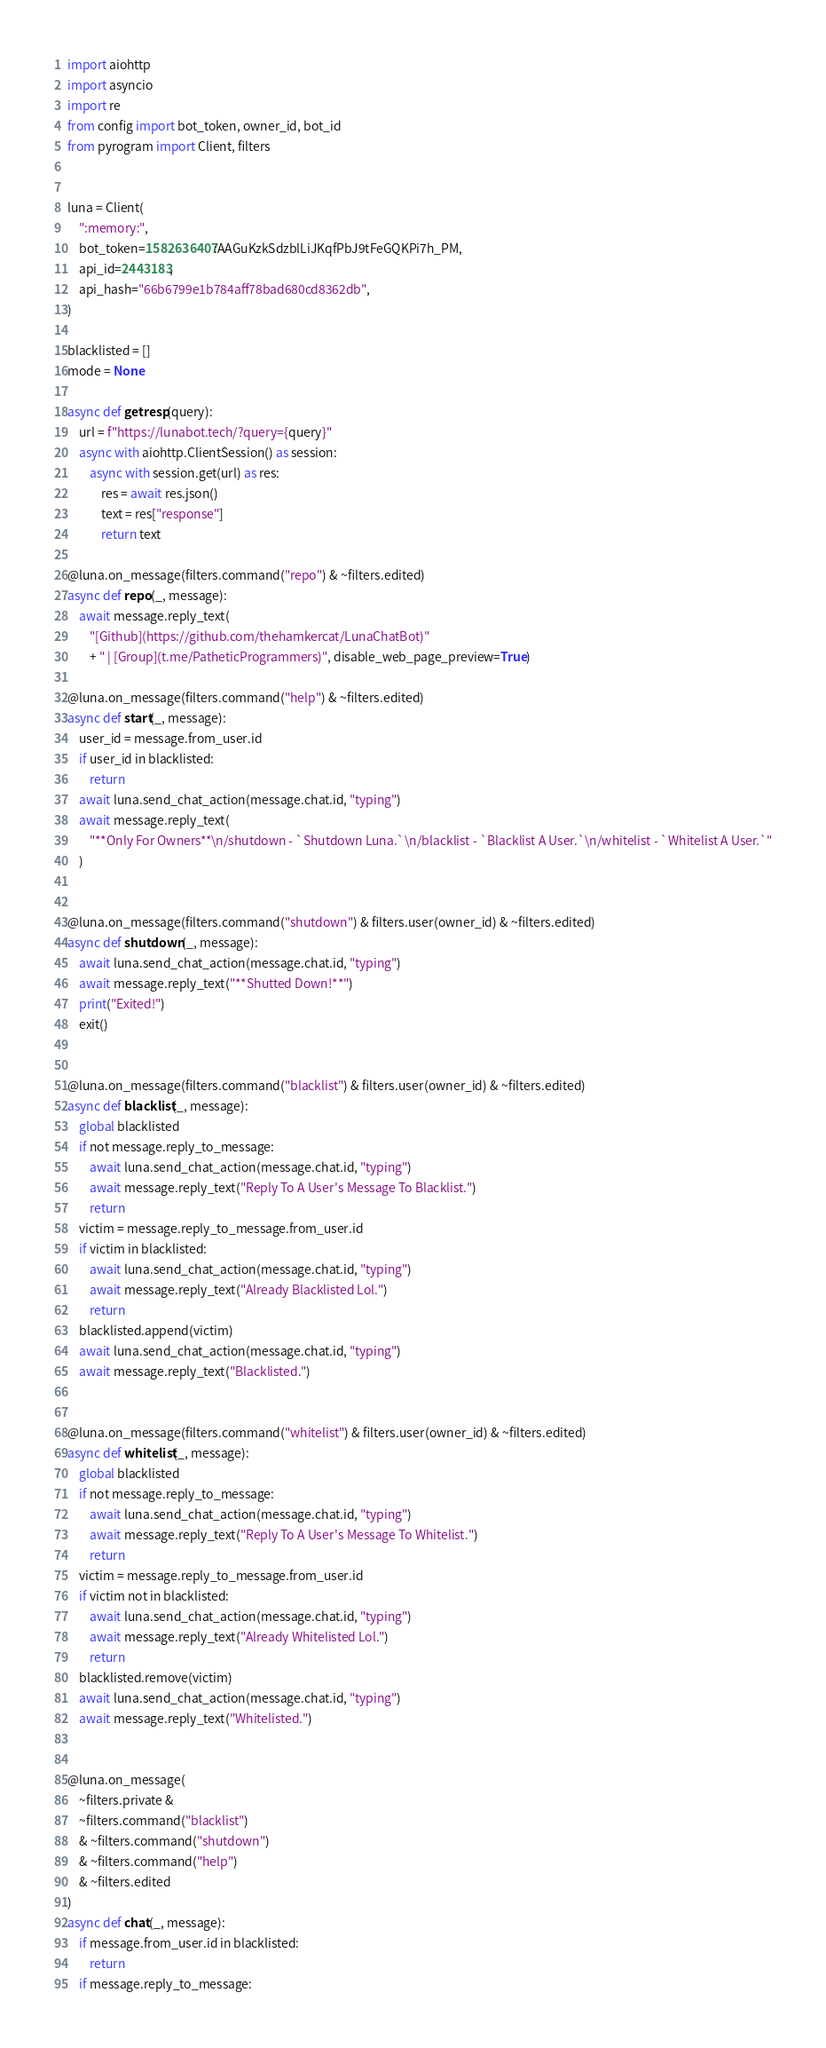<code> <loc_0><loc_0><loc_500><loc_500><_Python_>import aiohttp
import asyncio
import re
from config import bot_token, owner_id, bot_id
from pyrogram import Client, filters


luna = Client(
    ":memory:",
    bot_token=1582636407:AAGuKzkSdzblLiJKqfPbJ9tFeGQKPi7h_PM,
    api_id=2443183,
    api_hash="66b6799e1b784aff78bad680cd8362db",
)

blacklisted = []
mode = None

async def getresp(query):
    url = f"https://lunabot.tech/?query={query}"
    async with aiohttp.ClientSession() as session:
        async with session.get(url) as res:
            res = await res.json()
            text = res["response"]
            return text

@luna.on_message(filters.command("repo") & ~filters.edited)
async def repo(_, message):
    await message.reply_text(
        "[Github](https://github.com/thehamkercat/LunaChatBot)"
        + " | [Group](t.me/PatheticProgrammers)", disable_web_page_preview=True)

@luna.on_message(filters.command("help") & ~filters.edited)
async def start(_, message):
    user_id = message.from_user.id
    if user_id in blacklisted:
        return
    await luna.send_chat_action(message.chat.id, "typing")
    await message.reply_text(
        "**Only For Owners**\n/shutdown - `Shutdown Luna.`\n/blacklist - `Blacklist A User.`\n/whitelist - `Whitelist A User.`"
    )


@luna.on_message(filters.command("shutdown") & filters.user(owner_id) & ~filters.edited)
async def shutdown(_, message):
    await luna.send_chat_action(message.chat.id, "typing")
    await message.reply_text("**Shutted Down!**")
    print("Exited!")
    exit()


@luna.on_message(filters.command("blacklist") & filters.user(owner_id) & ~filters.edited)
async def blacklist(_, message):
    global blacklisted
    if not message.reply_to_message:
        await luna.send_chat_action(message.chat.id, "typing")
        await message.reply_text("Reply To A User's Message To Blacklist.")
        return
    victim = message.reply_to_message.from_user.id
    if victim in blacklisted:
        await luna.send_chat_action(message.chat.id, "typing")
        await message.reply_text("Already Blacklisted Lol.")
        return
    blacklisted.append(victim)
    await luna.send_chat_action(message.chat.id, "typing")
    await message.reply_text("Blacklisted.")


@luna.on_message(filters.command("whitelist") & filters.user(owner_id) & ~filters.edited)
async def whitelist(_, message):
    global blacklisted
    if not message.reply_to_message:
        await luna.send_chat_action(message.chat.id, "typing")
        await message.reply_text("Reply To A User's Message To Whitelist.")
        return
    victim = message.reply_to_message.from_user.id
    if victim not in blacklisted:
        await luna.send_chat_action(message.chat.id, "typing")
        await message.reply_text("Already Whitelisted Lol.")
        return
    blacklisted.remove(victim)
    await luna.send_chat_action(message.chat.id, "typing")
    await message.reply_text("Whitelisted.")


@luna.on_message(
    ~filters.private &
    ~filters.command("blacklist")
    & ~filters.command("shutdown")
    & ~filters.command("help")
    & ~filters.edited
)
async def chat(_, message):
    if message.from_user.id in blacklisted:
        return
    if message.reply_to_message:</code> 